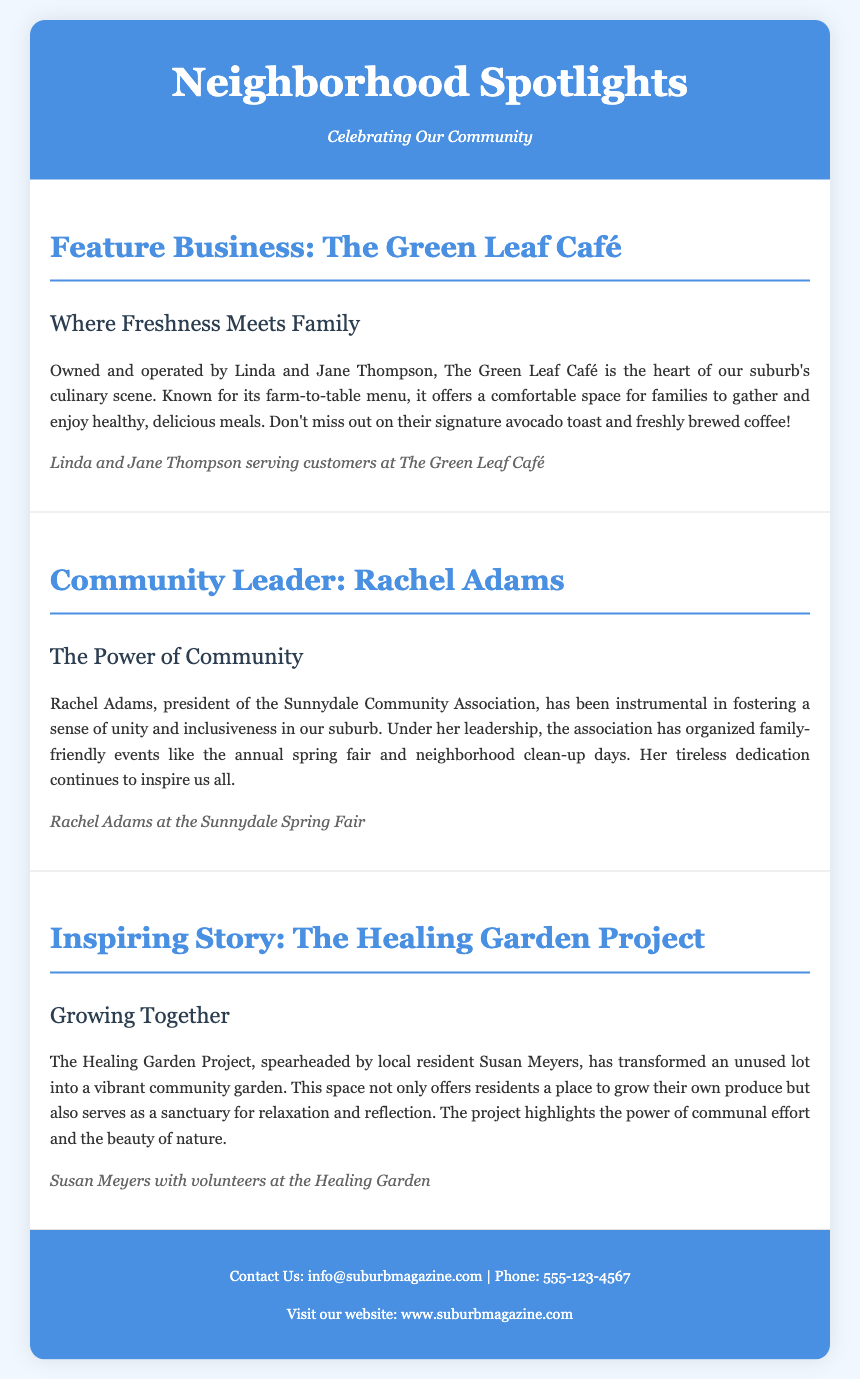what is the name of the feature business? The document highlights The Green Leaf Café as the featured business.
Answer: The Green Leaf Café who are the owners of The Green Leaf Café? The owners of The Green Leaf Café are identified as Linda and Jane Thompson.
Answer: Linda and Jane Thompson who is the president of the Sunnydale Community Association? Rachel Adams is mentioned as the president in the section about the community leader.
Answer: Rachel Adams what project did Susan Meyers spearhead? The document describes the initiative led by Susan Meyers as The Healing Garden Project.
Answer: The Healing Garden Project what type of menu does The Green Leaf Café offer? The café is known for its farm-to-table menu, emphasizing fresh, healthy meals.
Answer: farm-to-table menu how has Rachel Adams contributed to the community? Under her leadership, Rachel Adams has organized family-friendly events in the suburb.
Answer: organized family-friendly events what is one of the signature items mentioned at The Green Leaf Café? The document highlights signature avocado toast as a popular menu item.
Answer: signature avocado toast which event is associated with Rachel Adams? The annual spring fair is one of the events organized under her leadership.
Answer: annual spring fair what does the Healing Garden Project offer residents? The project provides a place for residents to grow their own produce.
Answer: a place to grow their own produce 